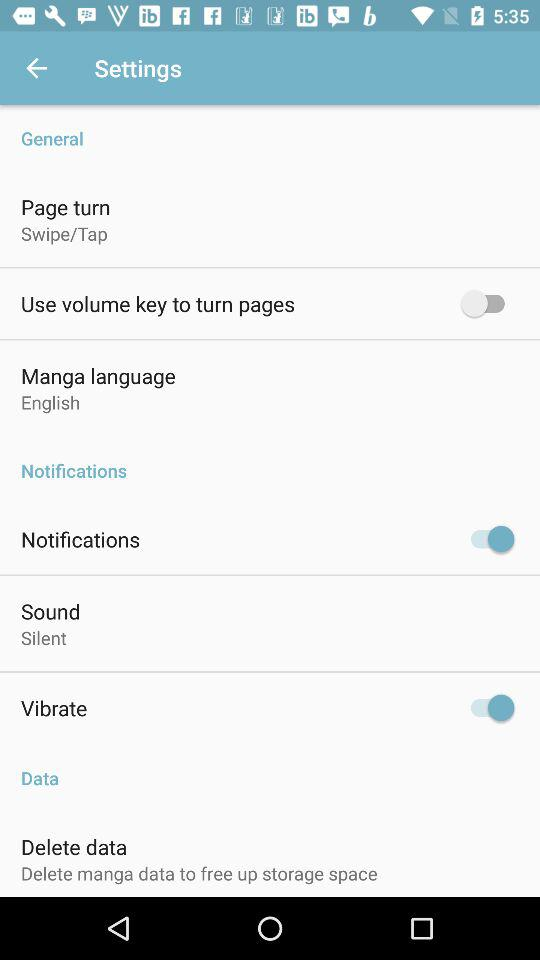How many more items are there in the Notifications section than in the General section?
Answer the question using a single word or phrase. 2 